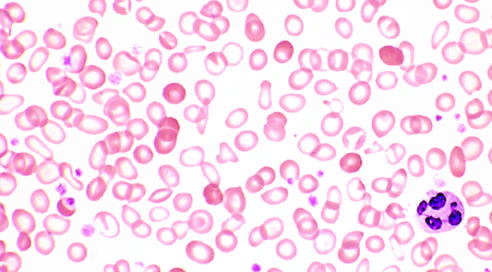does scattered, fully hemoglobinized cells, from a recent blood transfusion, stand out in contrast?
Answer the question using a single word or phrase. Yes 